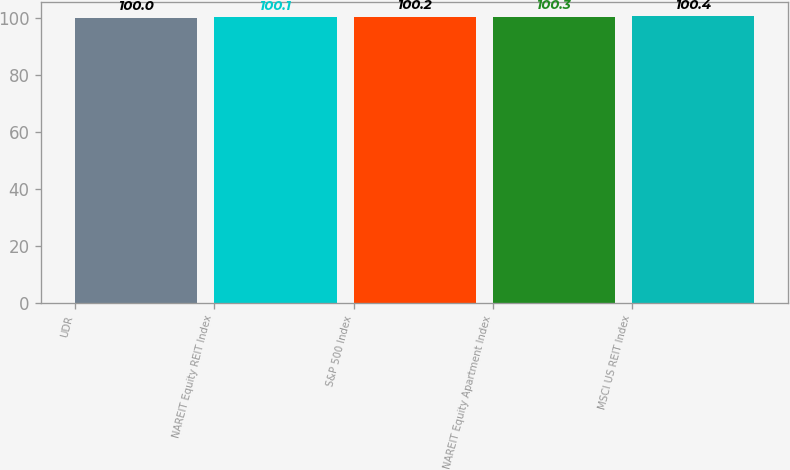Convert chart. <chart><loc_0><loc_0><loc_500><loc_500><bar_chart><fcel>UDR<fcel>NAREIT Equity REIT Index<fcel>S&P 500 Index<fcel>NAREIT Equity Apartment Index<fcel>MSCI US REIT Index<nl><fcel>100<fcel>100.1<fcel>100.2<fcel>100.3<fcel>100.4<nl></chart> 